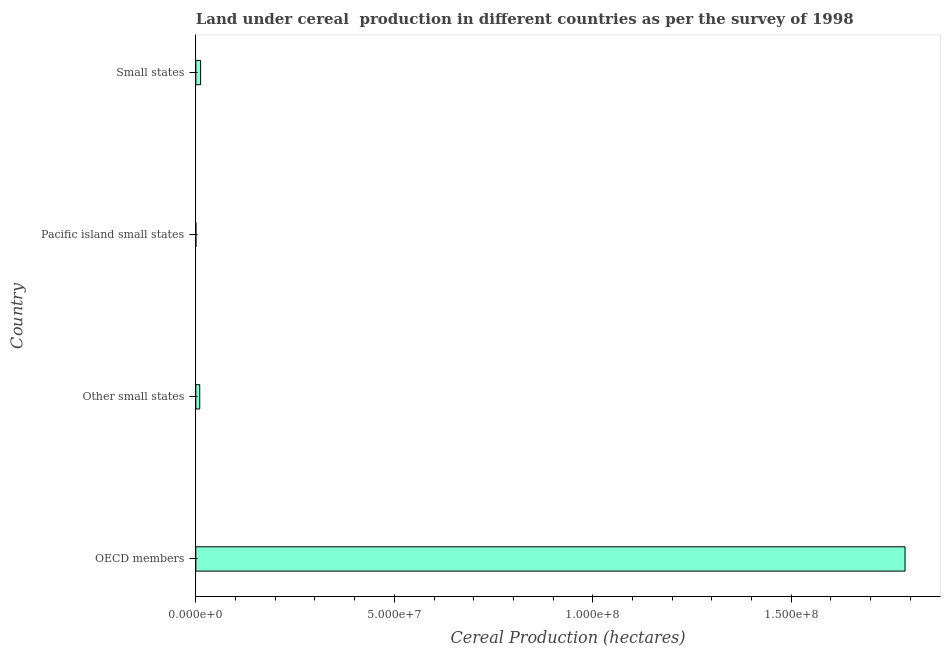Does the graph contain grids?
Give a very brief answer. No. What is the title of the graph?
Keep it short and to the point. Land under cereal  production in different countries as per the survey of 1998. What is the label or title of the X-axis?
Offer a terse response. Cereal Production (hectares). What is the label or title of the Y-axis?
Make the answer very short. Country. What is the land under cereal production in Small states?
Your answer should be compact. 1.21e+06. Across all countries, what is the maximum land under cereal production?
Offer a terse response. 1.79e+08. Across all countries, what is the minimum land under cereal production?
Provide a short and direct response. 1.04e+04. In which country was the land under cereal production maximum?
Give a very brief answer. OECD members. In which country was the land under cereal production minimum?
Make the answer very short. Pacific island small states. What is the sum of the land under cereal production?
Offer a very short reply. 1.81e+08. What is the difference between the land under cereal production in Other small states and Pacific island small states?
Offer a terse response. 9.74e+05. What is the average land under cereal production per country?
Your response must be concise. 4.52e+07. What is the median land under cereal production?
Provide a short and direct response. 1.09e+06. In how many countries, is the land under cereal production greater than 70000000 hectares?
Offer a very short reply. 1. What is the ratio of the land under cereal production in OECD members to that in Small states?
Make the answer very short. 148.18. What is the difference between the highest and the second highest land under cereal production?
Your answer should be compact. 1.77e+08. What is the difference between the highest and the lowest land under cereal production?
Your answer should be very brief. 1.79e+08. In how many countries, is the land under cereal production greater than the average land under cereal production taken over all countries?
Your answer should be compact. 1. How many bars are there?
Provide a short and direct response. 4. What is the Cereal Production (hectares) of OECD members?
Ensure brevity in your answer.  1.79e+08. What is the Cereal Production (hectares) in Other small states?
Provide a short and direct response. 9.84e+05. What is the Cereal Production (hectares) in Pacific island small states?
Keep it short and to the point. 1.04e+04. What is the Cereal Production (hectares) in Small states?
Your answer should be very brief. 1.21e+06. What is the difference between the Cereal Production (hectares) in OECD members and Other small states?
Your response must be concise. 1.78e+08. What is the difference between the Cereal Production (hectares) in OECD members and Pacific island small states?
Make the answer very short. 1.79e+08. What is the difference between the Cereal Production (hectares) in OECD members and Small states?
Offer a terse response. 1.77e+08. What is the difference between the Cereal Production (hectares) in Other small states and Pacific island small states?
Offer a terse response. 9.74e+05. What is the difference between the Cereal Production (hectares) in Other small states and Small states?
Make the answer very short. -2.22e+05. What is the difference between the Cereal Production (hectares) in Pacific island small states and Small states?
Your answer should be very brief. -1.20e+06. What is the ratio of the Cereal Production (hectares) in OECD members to that in Other small states?
Make the answer very short. 181.57. What is the ratio of the Cereal Production (hectares) in OECD members to that in Pacific island small states?
Keep it short and to the point. 1.71e+04. What is the ratio of the Cereal Production (hectares) in OECD members to that in Small states?
Provide a succinct answer. 148.18. What is the ratio of the Cereal Production (hectares) in Other small states to that in Pacific island small states?
Keep it short and to the point. 94.27. What is the ratio of the Cereal Production (hectares) in Other small states to that in Small states?
Provide a short and direct response. 0.82. What is the ratio of the Cereal Production (hectares) in Pacific island small states to that in Small states?
Offer a terse response. 0.01. 